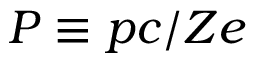Convert formula to latex. <formula><loc_0><loc_0><loc_500><loc_500>P \equiv p c / Z e</formula> 